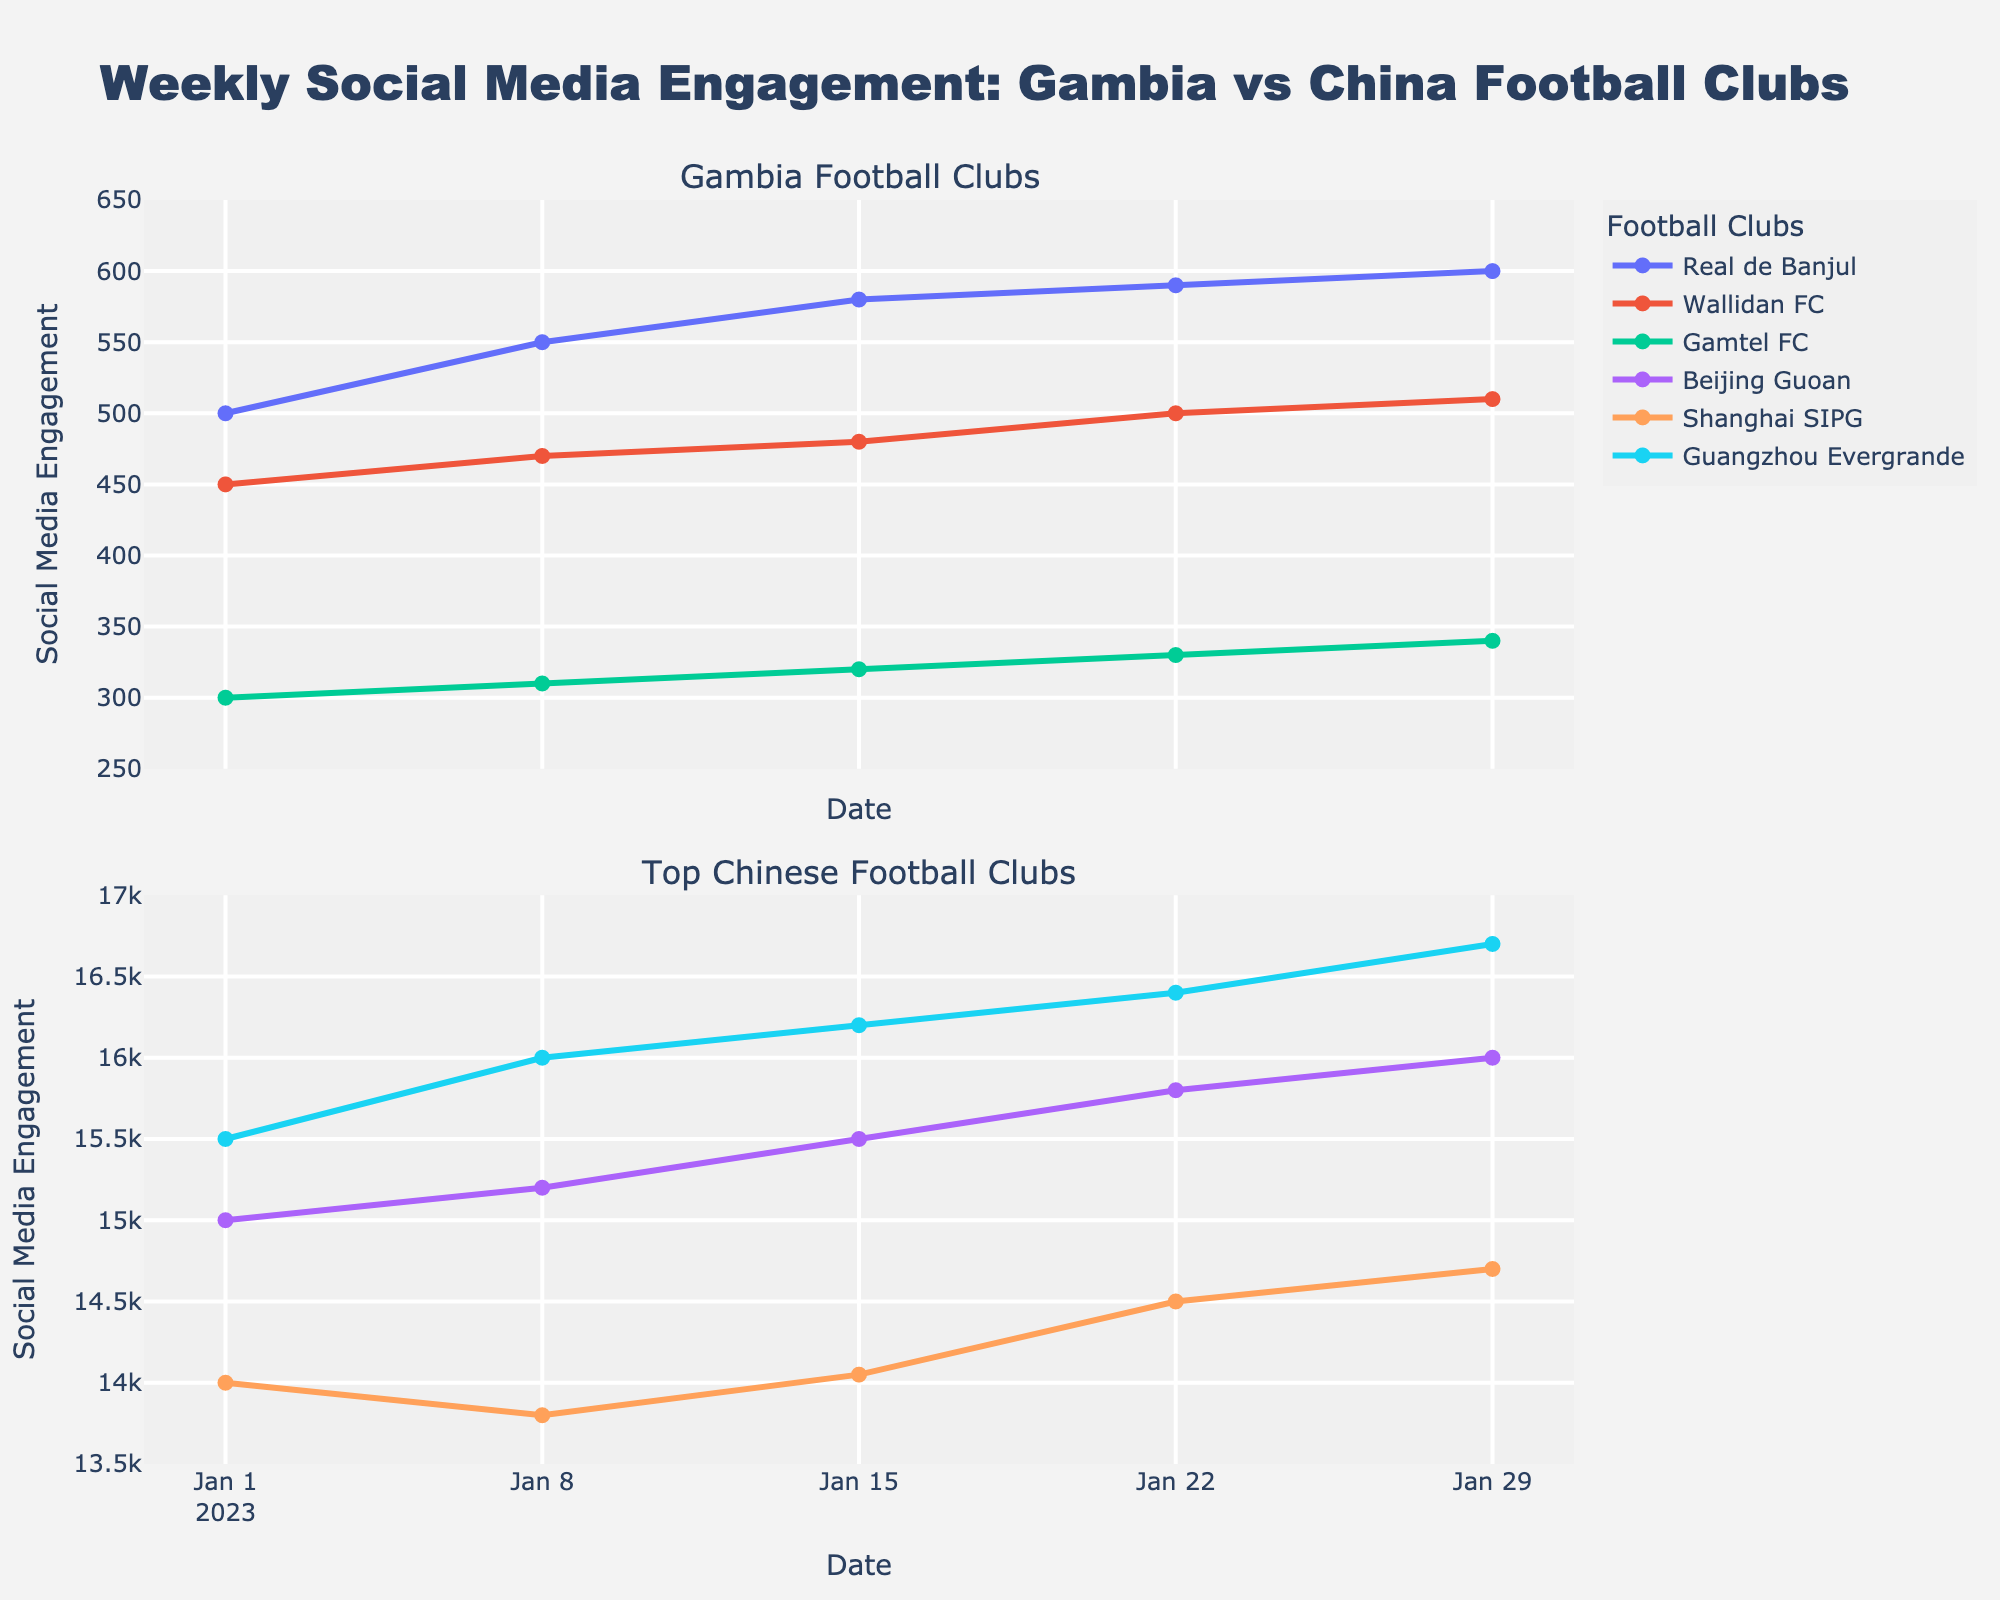What is the title of the figure? The title of the figure is written at the top center of the plot.
Answer: "Weekly Social Media Engagement: Gambia vs China Football Clubs" What is the average social media engagement of Wallidan FC for the given weeks? First, list the engagements for Wallidan FC (450, 470, 480, 500, 510). Sum them up: (450 + 470 + 480 + 500 + 510) = 2410. Then, divide by the number of weeks (5).
Answer: 482 Which football club has the highest engagement on January 22, 2023? Check the engagement values for all clubs on January 22, 2023. The values are: Real de Banjul (590), Wallidan FC (500), Gamtel FC (330), Beijing Guoan (15800), Shanghai SIPG (14500), Guangzhou Evergrande (16400). The highest engagement is for Guangzhou Evergrande with 16400.
Answer: Guangzhou Evergrande How does the social media engagement trend of Real de Banjul compare to Gamtel FC over the given period? Observe the trend lines for both clubs in the top subplot. Real de Banjul shows a consistent increase, whereas Gamtel FC also increases but at a slower rate.
Answer: Real de Banjul: increasing rapidly; Gamtel FC: increasing slowly What is the difference in social media engagement between Beijing Guoan and Real de Banjul on January 29, 2023? Engagement on January 29, 2023: Beijing Guoan (16000), Real de Banjul (600). Subtract Real de Banjul's engagement from Beijing Guoan's: 16000 - 600 = 15400.
Answer: 15400 How does the social media engagement of Shanghai SIPG change from January 1 to January 29, 2023? Identify the initial and final engagement values for Shanghai SIPG. January 1: 14000, January 29: 14700. The change is: 14700 - 14000 = 700, showing an increase.
Answer: +700 Which club shows the most stable engagement trend among the Chinese clubs? Compare the engagement trend lines for Beijing Guoan, Shanghai SIPG, and Guangzhou Evergrande in the bottom subplot. Beijing Guoan's trend line is the most flat indicating stability.
Answer: Beijing Guoan What is the ratio of the highest Gambia club engagement to the lowest Chinese club engagement on January 8, 2023? Highest Gambia club engagement on January 8, 2023 is Real de Banjul (550). Lowest Chinese club engagement on the same date is Shanghai SIPG (13800). The ratio is 550 / 13800. Simplify: 55 / 1380 = 0.03986.
Answer: 0.03986 